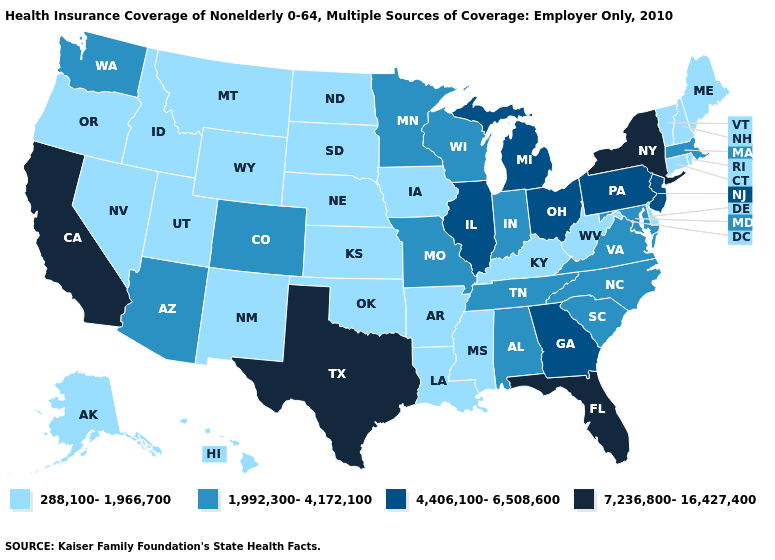Name the states that have a value in the range 7,236,800-16,427,400?
Short answer required. California, Florida, New York, Texas. Does South Carolina have a lower value than Georgia?
Keep it brief. Yes. What is the value of Kansas?
Concise answer only. 288,100-1,966,700. Which states have the lowest value in the USA?
Answer briefly. Alaska, Arkansas, Connecticut, Delaware, Hawaii, Idaho, Iowa, Kansas, Kentucky, Louisiana, Maine, Mississippi, Montana, Nebraska, Nevada, New Hampshire, New Mexico, North Dakota, Oklahoma, Oregon, Rhode Island, South Dakota, Utah, Vermont, West Virginia, Wyoming. Does the first symbol in the legend represent the smallest category?
Keep it brief. Yes. How many symbols are there in the legend?
Be succinct. 4. Name the states that have a value in the range 4,406,100-6,508,600?
Short answer required. Georgia, Illinois, Michigan, New Jersey, Ohio, Pennsylvania. Name the states that have a value in the range 7,236,800-16,427,400?
Answer briefly. California, Florida, New York, Texas. What is the value of North Carolina?
Quick response, please. 1,992,300-4,172,100. What is the value of Florida?
Be succinct. 7,236,800-16,427,400. Does the first symbol in the legend represent the smallest category?
Give a very brief answer. Yes. What is the value of Arizona?
Give a very brief answer. 1,992,300-4,172,100. What is the highest value in the USA?
Give a very brief answer. 7,236,800-16,427,400. Does New Mexico have the same value as North Carolina?
Give a very brief answer. No. Does the map have missing data?
Quick response, please. No. 